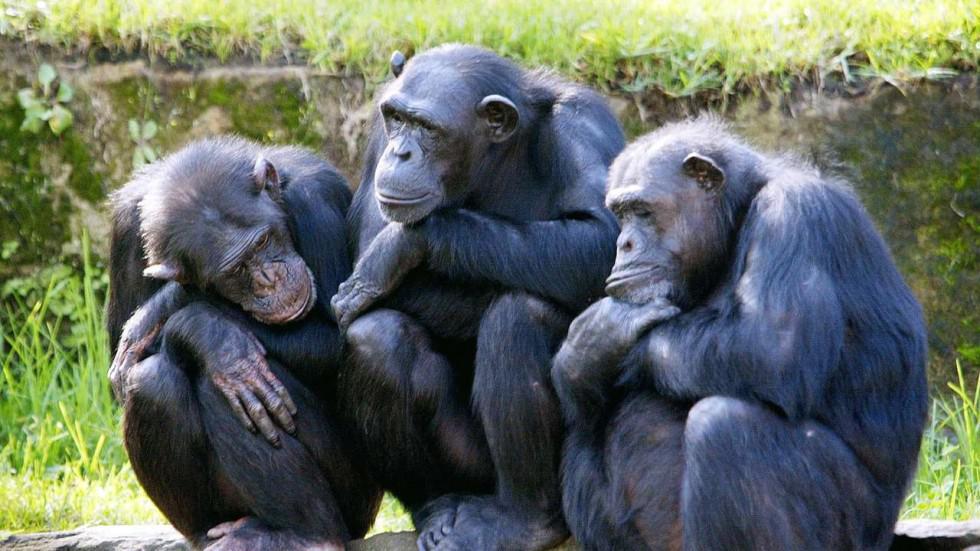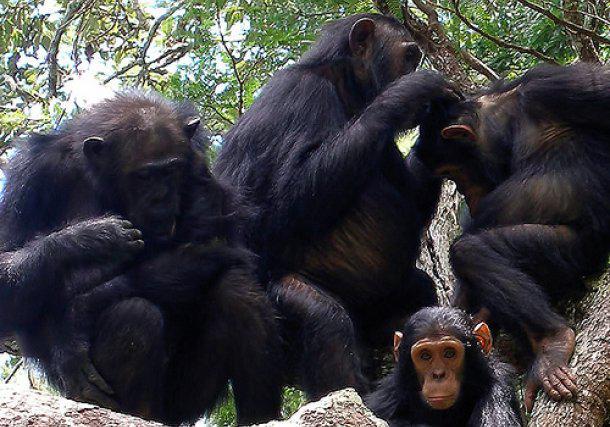The first image is the image on the left, the second image is the image on the right. For the images shown, is this caption "The image on the right contains two chimpanzees." true? Answer yes or no. No. The first image is the image on the left, the second image is the image on the right. Analyze the images presented: Is the assertion "None of the images has more than two chimpanzees present." valid? Answer yes or no. No. 